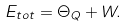<formula> <loc_0><loc_0><loc_500><loc_500>E _ { t o t } = \Theta _ { Q } + W .</formula> 